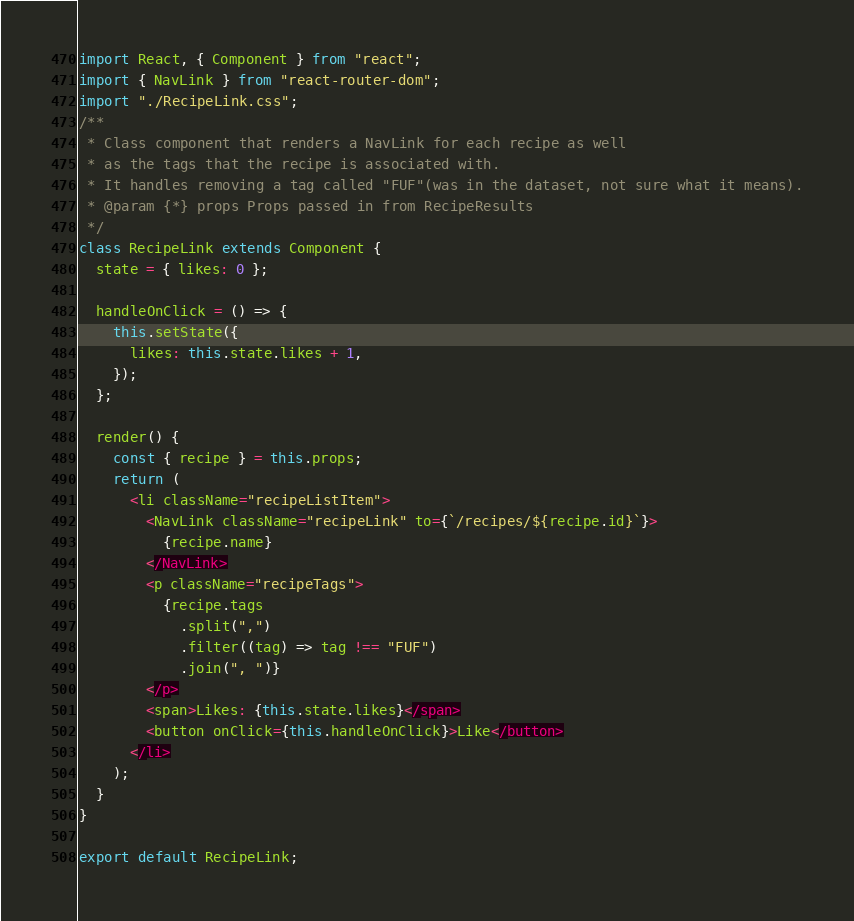<code> <loc_0><loc_0><loc_500><loc_500><_JavaScript_>import React, { Component } from "react";
import { NavLink } from "react-router-dom";
import "./RecipeLink.css";
/**
 * Class component that renders a NavLink for each recipe as well
 * as the tags that the recipe is associated with.
 * It handles removing a tag called "FUF"(was in the dataset, not sure what it means).
 * @param {*} props Props passed in from RecipeResults
 */
class RecipeLink extends Component {
  state = { likes: 0 };

  handleOnClick = () => {
    this.setState({
      likes: this.state.likes + 1,
    });
  };

  render() {
    const { recipe } = this.props;
    return (
      <li className="recipeListItem">
        <NavLink className="recipeLink" to={`/recipes/${recipe.id}`}>
          {recipe.name}
        </NavLink>
        <p className="recipeTags">
          {recipe.tags
            .split(",")
            .filter((tag) => tag !== "FUF")
            .join(", ")}
        </p>
        <span>Likes: {this.state.likes}</span>
        <button onClick={this.handleOnClick}>Like</button>
      </li>
    );
  }
}

export default RecipeLink;
</code> 